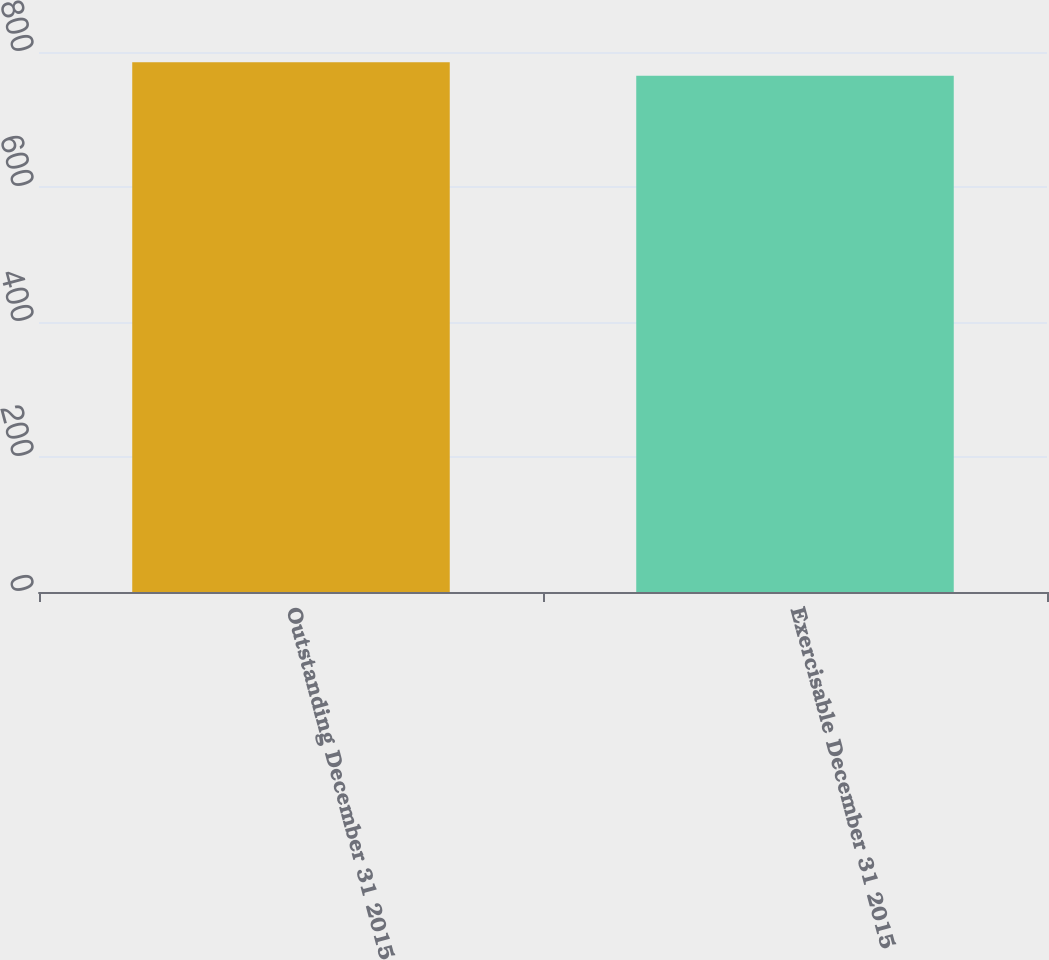Convert chart. <chart><loc_0><loc_0><loc_500><loc_500><bar_chart><fcel>Outstanding December 31 2015<fcel>Exercisable December 31 2015<nl><fcel>785<fcel>765<nl></chart> 